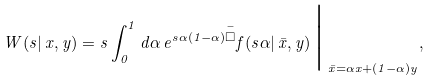<formula> <loc_0><loc_0><loc_500><loc_500>W ( s | \, x , y ) = s \int _ { 0 } ^ { 1 } d \alpha \, e ^ { s \alpha ( 1 - \alpha ) \overset { - } { \Box } } f ( s \alpha | \, \bar { x } , y ) \, \Big | _ { \, \bar { x } = \alpha x + ( 1 - \alpha ) y } ,</formula> 